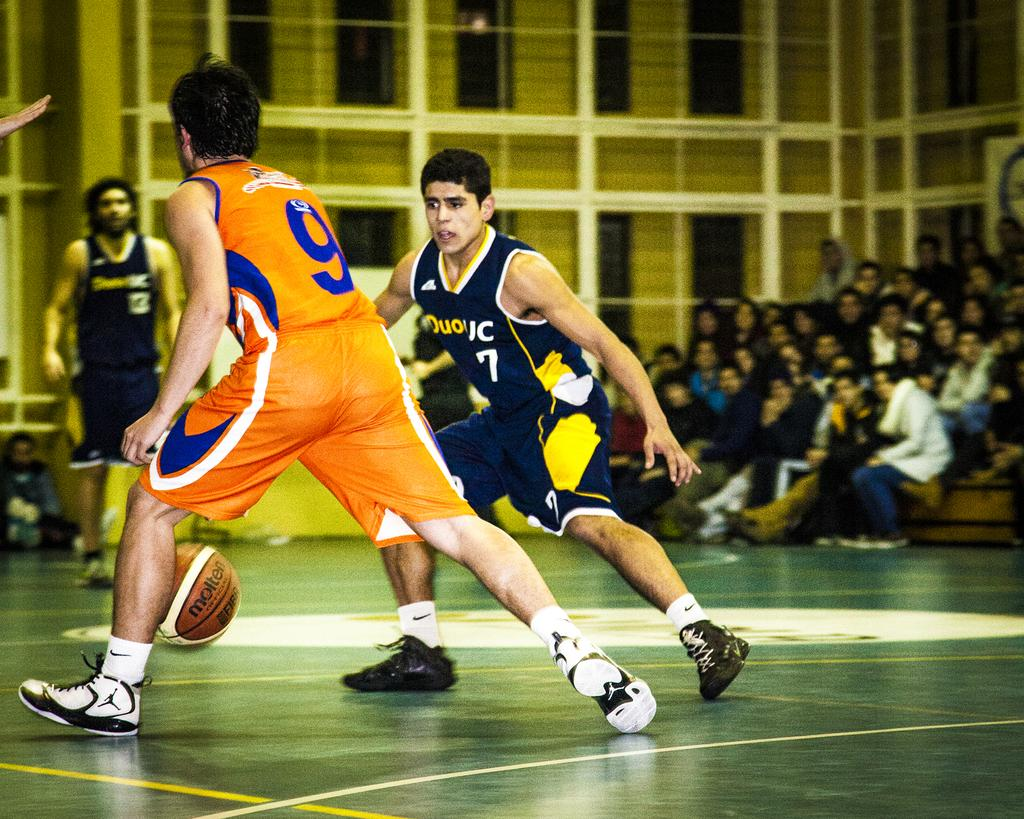<image>
Provide a brief description of the given image. the ball is between number 9 of the orange team and number 7 of the black team 